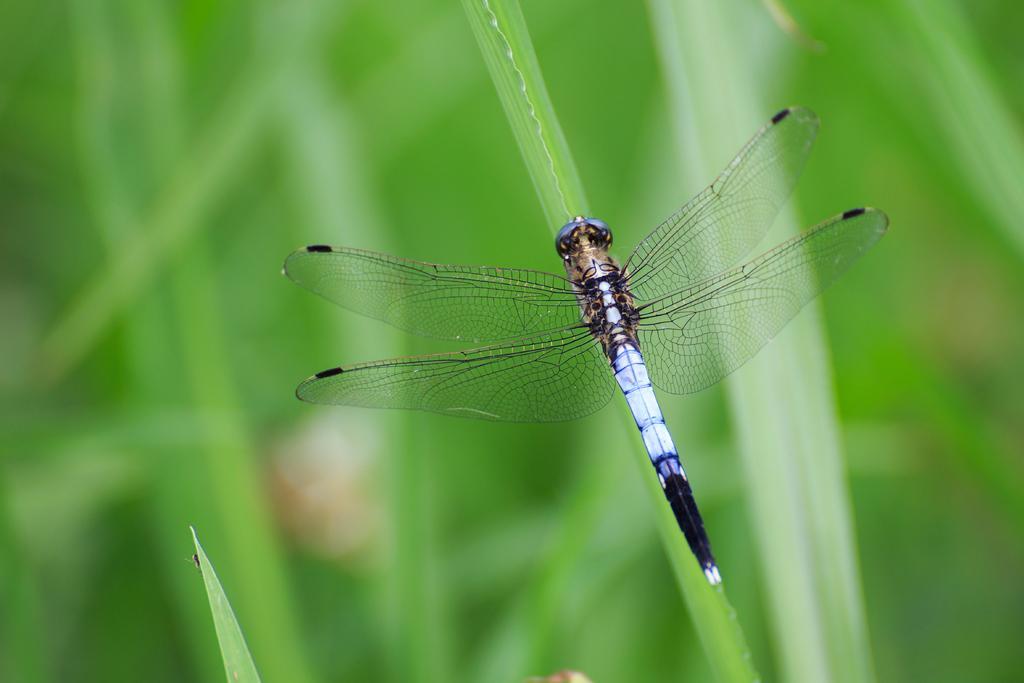How would you summarize this image in a sentence or two? In this picture there is a dragonfly on the leaf. At the back there are plants and the image is blurry. 